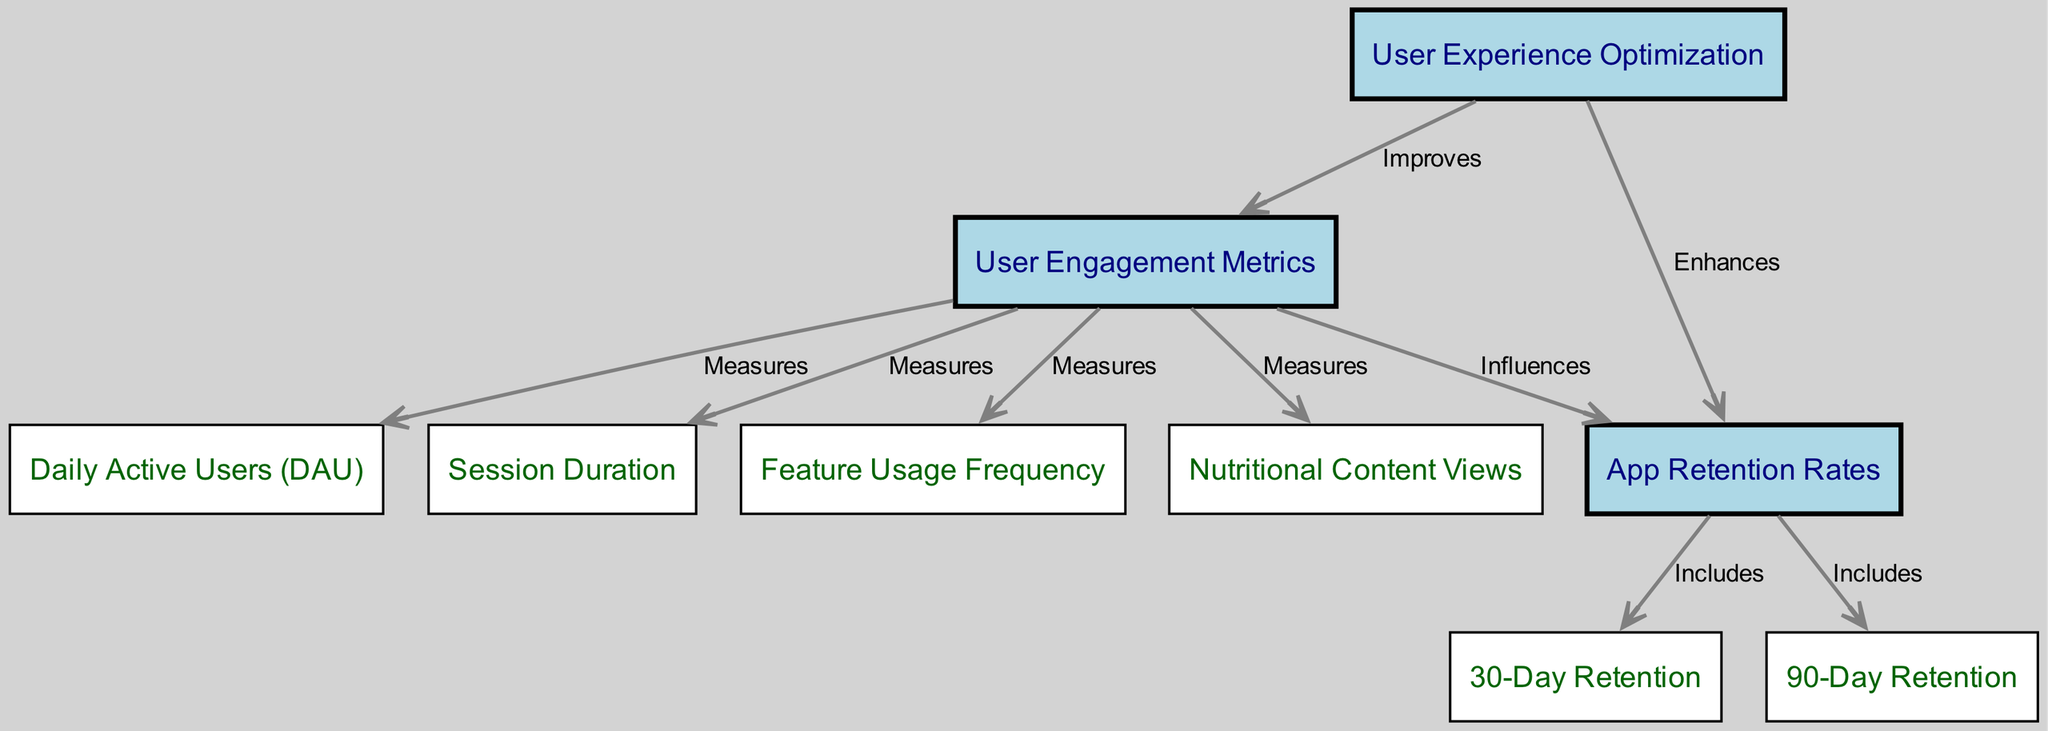What is the main theme of the concept map? The main theme of the diagram is about "User Engagement Metrics" and their correlation with "App Retention Rates." This is indicated by the central nodes and their connections.
Answer: User Engagement Metrics How many nodes are present in the diagram? I can count the nodes listed in the data. There are nine distinct nodes representing concepts related to user engagement and retention.
Answer: Nine What do "Daily Active Users" have a relationship with? From the edges in the diagram, "Daily Active Users" measures "User Engagement Metrics," indicating its role in quantifying user interactions.
Answer: User Engagement Metrics What influences "App Retention Rates"? The diagram clearly shows that "User Engagement Metrics" influences "App Retention Rates," as indicated by the directed edge.
Answer: User Engagement Metrics What includes "30-Day Retention"? The edge indicates that "30-Day Retention" is included in "App Retention Rates," which signifies it as a component of overall retention.
Answer: App Retention Rates How does "User Experience Optimization" relate to "User Engagement Metrics"? According to the diagram, "User Experience Optimization" improves "User Engagement Metrics," which implies that enhancing user experience can lead to better engagement metrics.
Answer: Improves Which node is enhanced by "User Experience Optimization"? The diagram shows that "User Experience Optimization" enhances "App Retention Rates," indicating a direct benefit of optimizing user experience on retaining users.
Answer: App Retention Rates What type of metrics does "Feature Usage Frequency" fall under? The diagram classifies "Feature Usage Frequency" as one of the measures within "User Engagement Metrics," thus it directly relates to user interactions.
Answer: Measures How many types of retention are included in the "App Retention Rates"? The edges indicate that there are two types of retention included – "30-Day Retention" and "90-Day Retention," giving a count of two categories.
Answer: Two 